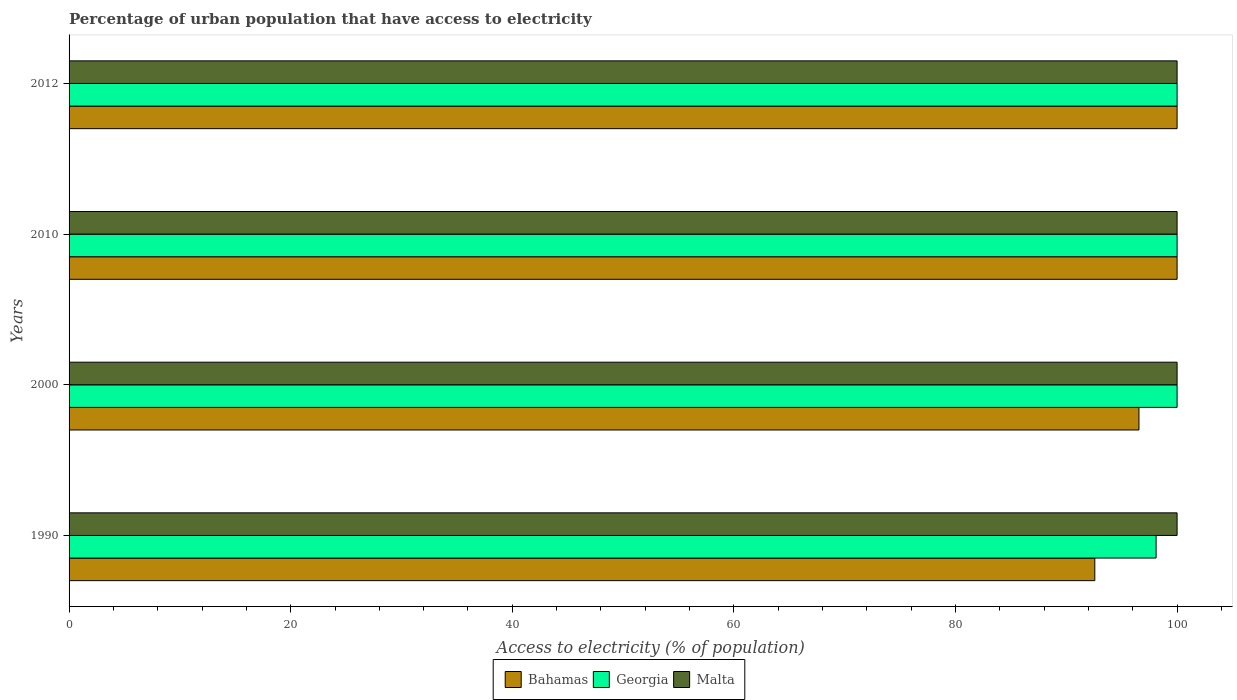Are the number of bars per tick equal to the number of legend labels?
Your response must be concise. Yes. How many bars are there on the 4th tick from the bottom?
Provide a succinct answer. 3. What is the label of the 3rd group of bars from the top?
Offer a very short reply. 2000. In how many cases, is the number of bars for a given year not equal to the number of legend labels?
Your answer should be very brief. 0. What is the percentage of urban population that have access to electricity in Bahamas in 2000?
Give a very brief answer. 96.56. Across all years, what is the maximum percentage of urban population that have access to electricity in Bahamas?
Ensure brevity in your answer.  100. Across all years, what is the minimum percentage of urban population that have access to electricity in Bahamas?
Provide a succinct answer. 92.57. In which year was the percentage of urban population that have access to electricity in Malta minimum?
Your answer should be very brief. 1990. What is the total percentage of urban population that have access to electricity in Bahamas in the graph?
Ensure brevity in your answer.  389.13. What is the difference between the percentage of urban population that have access to electricity in Bahamas in 1990 and that in 2012?
Your answer should be very brief. -7.43. What is the difference between the percentage of urban population that have access to electricity in Georgia in 1990 and the percentage of urban population that have access to electricity in Malta in 2010?
Offer a terse response. -1.89. What is the average percentage of urban population that have access to electricity in Bahamas per year?
Give a very brief answer. 97.28. In the year 2010, what is the difference between the percentage of urban population that have access to electricity in Malta and percentage of urban population that have access to electricity in Georgia?
Your answer should be compact. 0. In how many years, is the percentage of urban population that have access to electricity in Bahamas greater than 52 %?
Offer a terse response. 4. Is the percentage of urban population that have access to electricity in Georgia in 1990 less than that in 2000?
Provide a short and direct response. Yes. What is the difference between the highest and the lowest percentage of urban population that have access to electricity in Bahamas?
Your answer should be very brief. 7.43. Is the sum of the percentage of urban population that have access to electricity in Bahamas in 1990 and 2000 greater than the maximum percentage of urban population that have access to electricity in Georgia across all years?
Make the answer very short. Yes. What does the 2nd bar from the top in 2010 represents?
Offer a very short reply. Georgia. What does the 1st bar from the bottom in 2000 represents?
Keep it short and to the point. Bahamas. Is it the case that in every year, the sum of the percentage of urban population that have access to electricity in Georgia and percentage of urban population that have access to electricity in Malta is greater than the percentage of urban population that have access to electricity in Bahamas?
Your answer should be compact. Yes. How many bars are there?
Your answer should be very brief. 12. How many years are there in the graph?
Your answer should be very brief. 4. What is the difference between two consecutive major ticks on the X-axis?
Offer a very short reply. 20. Does the graph contain any zero values?
Your answer should be very brief. No. Does the graph contain grids?
Keep it short and to the point. No. What is the title of the graph?
Offer a terse response. Percentage of urban population that have access to electricity. What is the label or title of the X-axis?
Give a very brief answer. Access to electricity (% of population). What is the label or title of the Y-axis?
Give a very brief answer. Years. What is the Access to electricity (% of population) of Bahamas in 1990?
Your answer should be compact. 92.57. What is the Access to electricity (% of population) in Georgia in 1990?
Provide a succinct answer. 98.11. What is the Access to electricity (% of population) in Bahamas in 2000?
Give a very brief answer. 96.56. What is the Access to electricity (% of population) in Georgia in 2000?
Provide a succinct answer. 100. What is the Access to electricity (% of population) in Malta in 2000?
Offer a terse response. 100. What is the Access to electricity (% of population) of Bahamas in 2010?
Keep it short and to the point. 100. What is the Access to electricity (% of population) of Georgia in 2010?
Make the answer very short. 100. What is the Access to electricity (% of population) of Bahamas in 2012?
Give a very brief answer. 100. What is the Access to electricity (% of population) of Georgia in 2012?
Offer a terse response. 100. What is the Access to electricity (% of population) of Malta in 2012?
Provide a succinct answer. 100. Across all years, what is the maximum Access to electricity (% of population) in Georgia?
Give a very brief answer. 100. Across all years, what is the minimum Access to electricity (% of population) in Bahamas?
Ensure brevity in your answer.  92.57. Across all years, what is the minimum Access to electricity (% of population) in Georgia?
Offer a terse response. 98.11. What is the total Access to electricity (% of population) of Bahamas in the graph?
Offer a terse response. 389.13. What is the total Access to electricity (% of population) of Georgia in the graph?
Offer a very short reply. 398.11. What is the difference between the Access to electricity (% of population) of Bahamas in 1990 and that in 2000?
Your answer should be very brief. -3.99. What is the difference between the Access to electricity (% of population) of Georgia in 1990 and that in 2000?
Offer a very short reply. -1.89. What is the difference between the Access to electricity (% of population) in Malta in 1990 and that in 2000?
Provide a succinct answer. 0. What is the difference between the Access to electricity (% of population) in Bahamas in 1990 and that in 2010?
Ensure brevity in your answer.  -7.43. What is the difference between the Access to electricity (% of population) in Georgia in 1990 and that in 2010?
Give a very brief answer. -1.89. What is the difference between the Access to electricity (% of population) in Bahamas in 1990 and that in 2012?
Your response must be concise. -7.43. What is the difference between the Access to electricity (% of population) in Georgia in 1990 and that in 2012?
Provide a succinct answer. -1.89. What is the difference between the Access to electricity (% of population) in Malta in 1990 and that in 2012?
Offer a terse response. 0. What is the difference between the Access to electricity (% of population) in Bahamas in 2000 and that in 2010?
Your answer should be very brief. -3.44. What is the difference between the Access to electricity (% of population) of Bahamas in 2000 and that in 2012?
Give a very brief answer. -3.44. What is the difference between the Access to electricity (% of population) of Georgia in 2000 and that in 2012?
Ensure brevity in your answer.  0. What is the difference between the Access to electricity (% of population) in Bahamas in 1990 and the Access to electricity (% of population) in Georgia in 2000?
Provide a short and direct response. -7.43. What is the difference between the Access to electricity (% of population) of Bahamas in 1990 and the Access to electricity (% of population) of Malta in 2000?
Your response must be concise. -7.43. What is the difference between the Access to electricity (% of population) of Georgia in 1990 and the Access to electricity (% of population) of Malta in 2000?
Your answer should be compact. -1.89. What is the difference between the Access to electricity (% of population) in Bahamas in 1990 and the Access to electricity (% of population) in Georgia in 2010?
Your answer should be very brief. -7.43. What is the difference between the Access to electricity (% of population) of Bahamas in 1990 and the Access to electricity (% of population) of Malta in 2010?
Your response must be concise. -7.43. What is the difference between the Access to electricity (% of population) in Georgia in 1990 and the Access to electricity (% of population) in Malta in 2010?
Offer a terse response. -1.89. What is the difference between the Access to electricity (% of population) of Bahamas in 1990 and the Access to electricity (% of population) of Georgia in 2012?
Your answer should be compact. -7.43. What is the difference between the Access to electricity (% of population) in Bahamas in 1990 and the Access to electricity (% of population) in Malta in 2012?
Provide a succinct answer. -7.43. What is the difference between the Access to electricity (% of population) in Georgia in 1990 and the Access to electricity (% of population) in Malta in 2012?
Ensure brevity in your answer.  -1.89. What is the difference between the Access to electricity (% of population) in Bahamas in 2000 and the Access to electricity (% of population) in Georgia in 2010?
Offer a very short reply. -3.44. What is the difference between the Access to electricity (% of population) in Bahamas in 2000 and the Access to electricity (% of population) in Malta in 2010?
Provide a short and direct response. -3.44. What is the difference between the Access to electricity (% of population) in Bahamas in 2000 and the Access to electricity (% of population) in Georgia in 2012?
Give a very brief answer. -3.44. What is the difference between the Access to electricity (% of population) in Bahamas in 2000 and the Access to electricity (% of population) in Malta in 2012?
Make the answer very short. -3.44. What is the difference between the Access to electricity (% of population) of Georgia in 2000 and the Access to electricity (% of population) of Malta in 2012?
Keep it short and to the point. 0. What is the difference between the Access to electricity (% of population) in Bahamas in 2010 and the Access to electricity (% of population) in Georgia in 2012?
Offer a terse response. 0. What is the difference between the Access to electricity (% of population) of Bahamas in 2010 and the Access to electricity (% of population) of Malta in 2012?
Your response must be concise. 0. What is the difference between the Access to electricity (% of population) in Georgia in 2010 and the Access to electricity (% of population) in Malta in 2012?
Make the answer very short. 0. What is the average Access to electricity (% of population) of Bahamas per year?
Offer a very short reply. 97.28. What is the average Access to electricity (% of population) of Georgia per year?
Offer a terse response. 99.53. In the year 1990, what is the difference between the Access to electricity (% of population) in Bahamas and Access to electricity (% of population) in Georgia?
Your response must be concise. -5.53. In the year 1990, what is the difference between the Access to electricity (% of population) of Bahamas and Access to electricity (% of population) of Malta?
Provide a succinct answer. -7.43. In the year 1990, what is the difference between the Access to electricity (% of population) in Georgia and Access to electricity (% of population) in Malta?
Keep it short and to the point. -1.89. In the year 2000, what is the difference between the Access to electricity (% of population) of Bahamas and Access to electricity (% of population) of Georgia?
Offer a terse response. -3.44. In the year 2000, what is the difference between the Access to electricity (% of population) of Bahamas and Access to electricity (% of population) of Malta?
Ensure brevity in your answer.  -3.44. In the year 2010, what is the difference between the Access to electricity (% of population) in Bahamas and Access to electricity (% of population) in Georgia?
Provide a succinct answer. 0. In the year 2010, what is the difference between the Access to electricity (% of population) in Bahamas and Access to electricity (% of population) in Malta?
Make the answer very short. 0. In the year 2010, what is the difference between the Access to electricity (% of population) of Georgia and Access to electricity (% of population) of Malta?
Keep it short and to the point. 0. In the year 2012, what is the difference between the Access to electricity (% of population) in Bahamas and Access to electricity (% of population) in Georgia?
Offer a very short reply. 0. In the year 2012, what is the difference between the Access to electricity (% of population) in Bahamas and Access to electricity (% of population) in Malta?
Your response must be concise. 0. What is the ratio of the Access to electricity (% of population) in Bahamas in 1990 to that in 2000?
Your response must be concise. 0.96. What is the ratio of the Access to electricity (% of population) in Georgia in 1990 to that in 2000?
Make the answer very short. 0.98. What is the ratio of the Access to electricity (% of population) in Malta in 1990 to that in 2000?
Keep it short and to the point. 1. What is the ratio of the Access to electricity (% of population) of Bahamas in 1990 to that in 2010?
Offer a terse response. 0.93. What is the ratio of the Access to electricity (% of population) of Georgia in 1990 to that in 2010?
Your answer should be compact. 0.98. What is the ratio of the Access to electricity (% of population) in Malta in 1990 to that in 2010?
Provide a short and direct response. 1. What is the ratio of the Access to electricity (% of population) of Bahamas in 1990 to that in 2012?
Your answer should be compact. 0.93. What is the ratio of the Access to electricity (% of population) of Georgia in 1990 to that in 2012?
Provide a short and direct response. 0.98. What is the ratio of the Access to electricity (% of population) of Bahamas in 2000 to that in 2010?
Ensure brevity in your answer.  0.97. What is the ratio of the Access to electricity (% of population) of Malta in 2000 to that in 2010?
Offer a terse response. 1. What is the ratio of the Access to electricity (% of population) in Bahamas in 2000 to that in 2012?
Make the answer very short. 0.97. What is the ratio of the Access to electricity (% of population) in Malta in 2000 to that in 2012?
Your response must be concise. 1. What is the ratio of the Access to electricity (% of population) in Malta in 2010 to that in 2012?
Provide a short and direct response. 1. What is the difference between the highest and the second highest Access to electricity (% of population) in Georgia?
Offer a very short reply. 0. What is the difference between the highest and the second highest Access to electricity (% of population) in Malta?
Keep it short and to the point. 0. What is the difference between the highest and the lowest Access to electricity (% of population) of Bahamas?
Offer a terse response. 7.43. What is the difference between the highest and the lowest Access to electricity (% of population) in Georgia?
Make the answer very short. 1.89. 